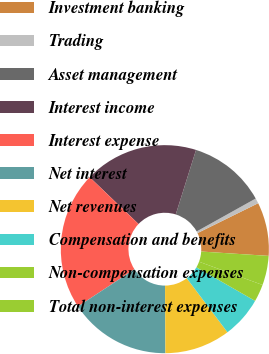Convert chart to OTSL. <chart><loc_0><loc_0><loc_500><loc_500><pie_chart><fcel>Investment banking<fcel>Trading<fcel>Asset management<fcel>Interest income<fcel>Interest expense<fcel>Net interest<fcel>Net revenues<fcel>Compensation and benefits<fcel>Non-compensation expenses<fcel>Total non-interest expenses<nl><fcel>8.31%<fcel>0.81%<fcel>12.06%<fcel>17.69%<fcel>21.43%<fcel>15.81%<fcel>10.19%<fcel>6.44%<fcel>2.69%<fcel>4.56%<nl></chart> 